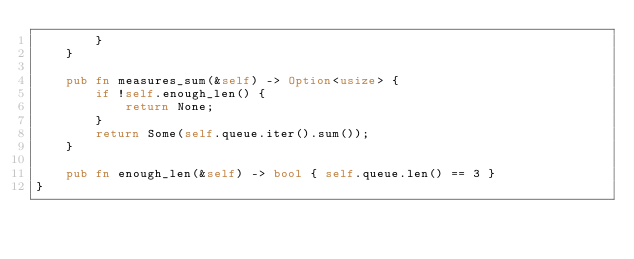Convert code to text. <code><loc_0><loc_0><loc_500><loc_500><_Rust_>        }
    }

    pub fn measures_sum(&self) -> Option<usize> {
        if !self.enough_len() {
            return None;
        }
        return Some(self.queue.iter().sum());
    }

    pub fn enough_len(&self) -> bool { self.queue.len() == 3 }
}
</code> 